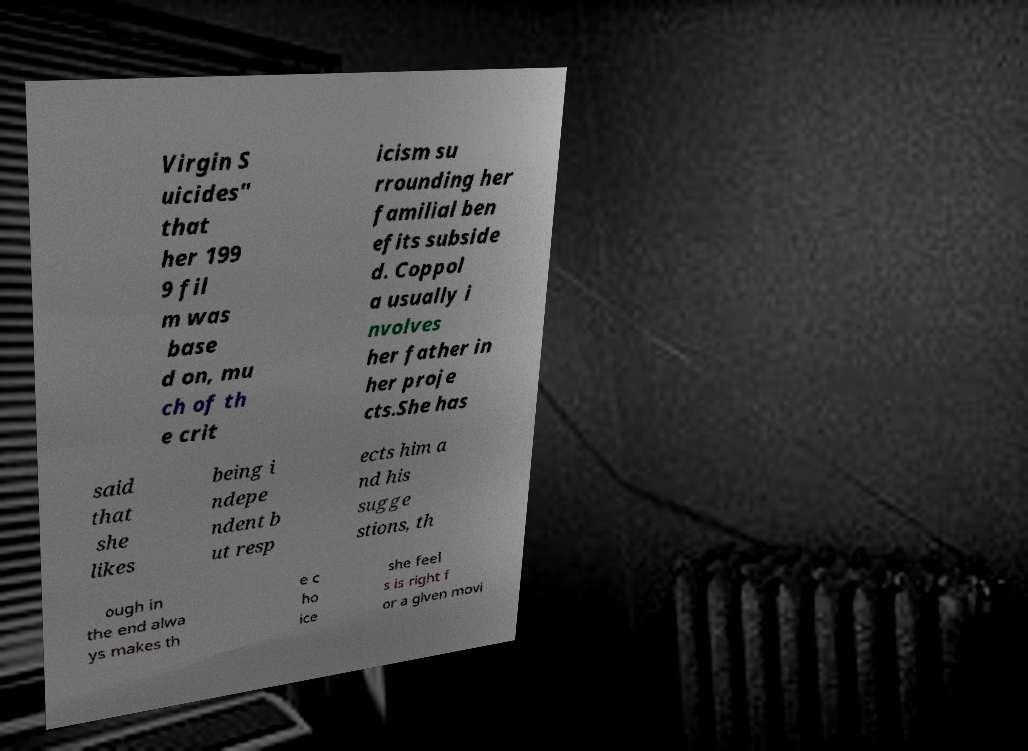For documentation purposes, I need the text within this image transcribed. Could you provide that? Virgin S uicides" that her 199 9 fil m was base d on, mu ch of th e crit icism su rrounding her familial ben efits subside d. Coppol a usually i nvolves her father in her proje cts.She has said that she likes being i ndepe ndent b ut resp ects him a nd his sugge stions, th ough in the end alwa ys makes th e c ho ice she feel s is right f or a given movi 